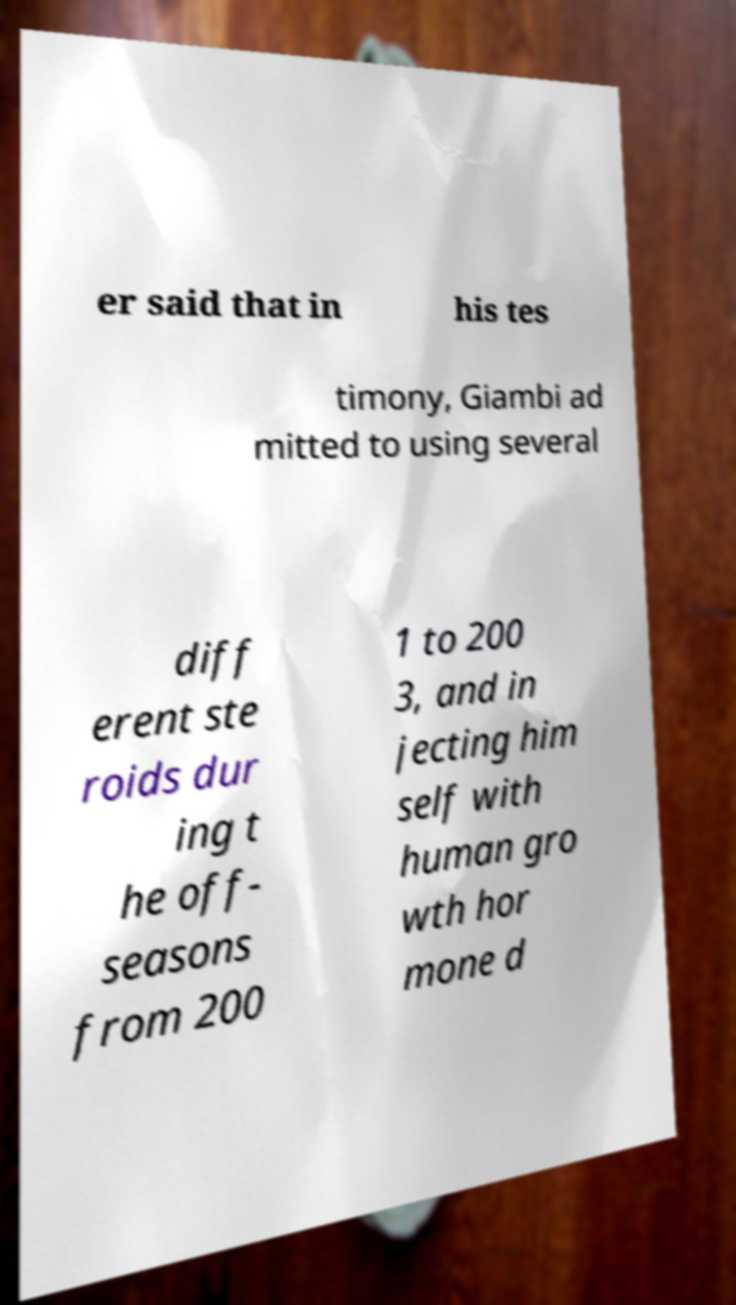Can you accurately transcribe the text from the provided image for me? er said that in his tes timony, Giambi ad mitted to using several diff erent ste roids dur ing t he off- seasons from 200 1 to 200 3, and in jecting him self with human gro wth hor mone d 